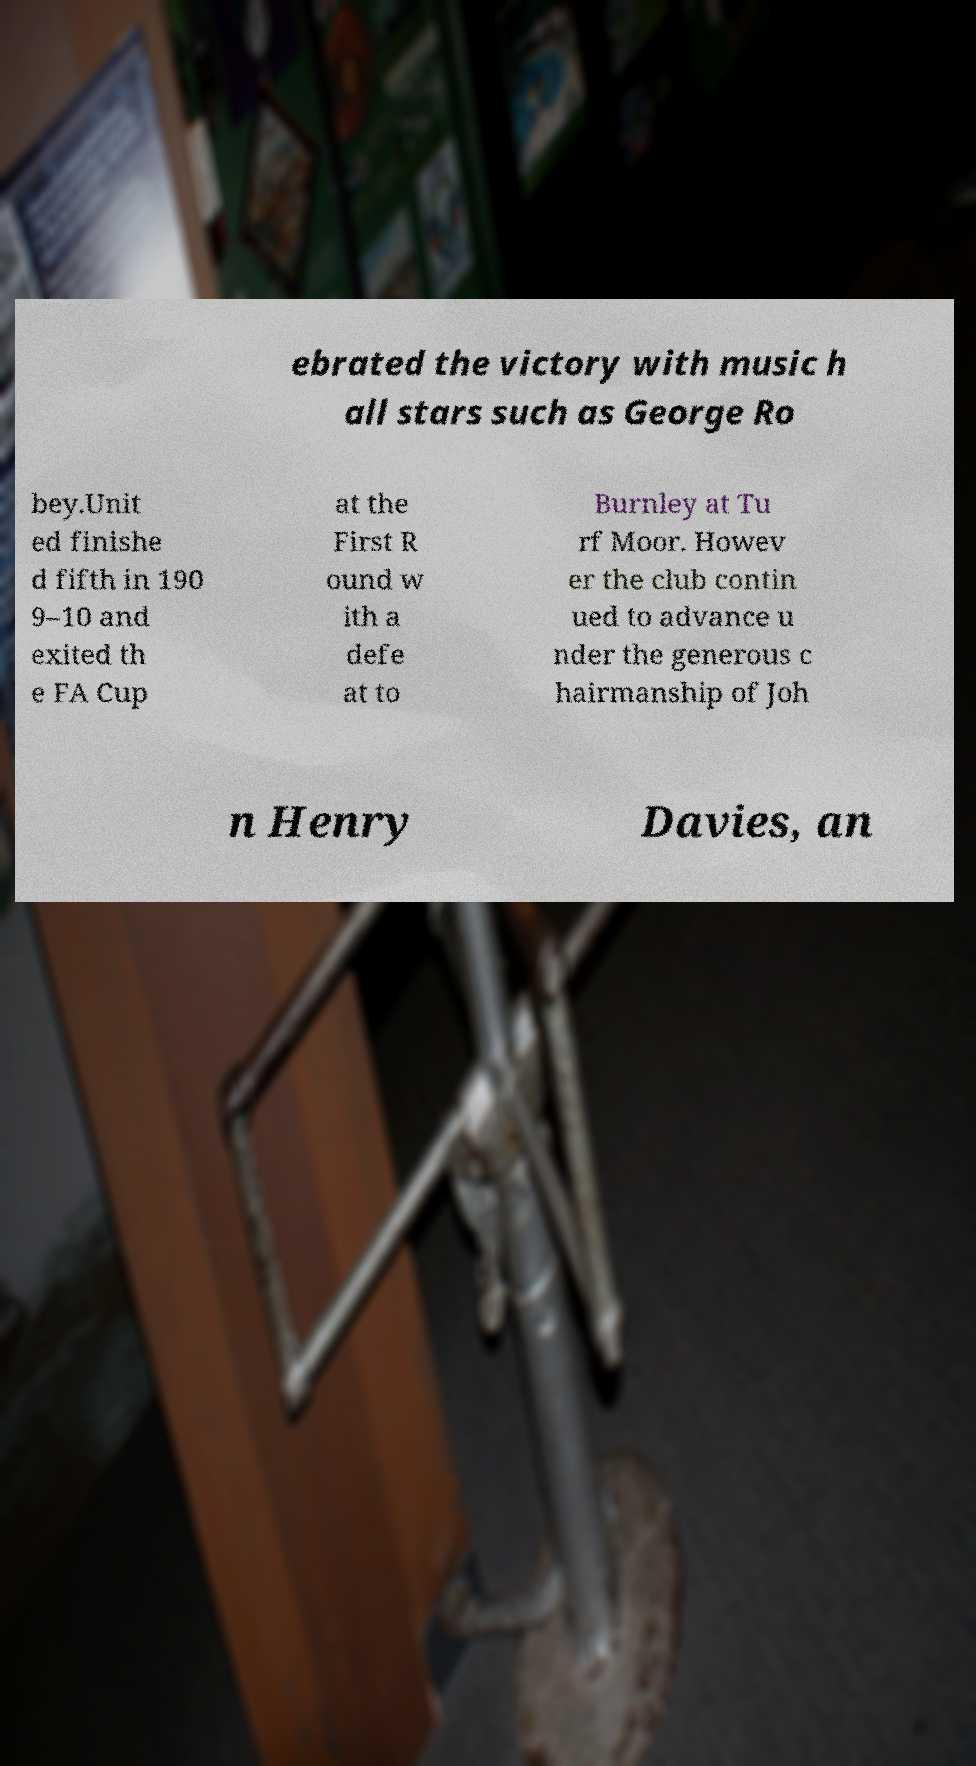Please identify and transcribe the text found in this image. ebrated the victory with music h all stars such as George Ro bey.Unit ed finishe d fifth in 190 9–10 and exited th e FA Cup at the First R ound w ith a defe at to Burnley at Tu rf Moor. Howev er the club contin ued to advance u nder the generous c hairmanship of Joh n Henry Davies, an 